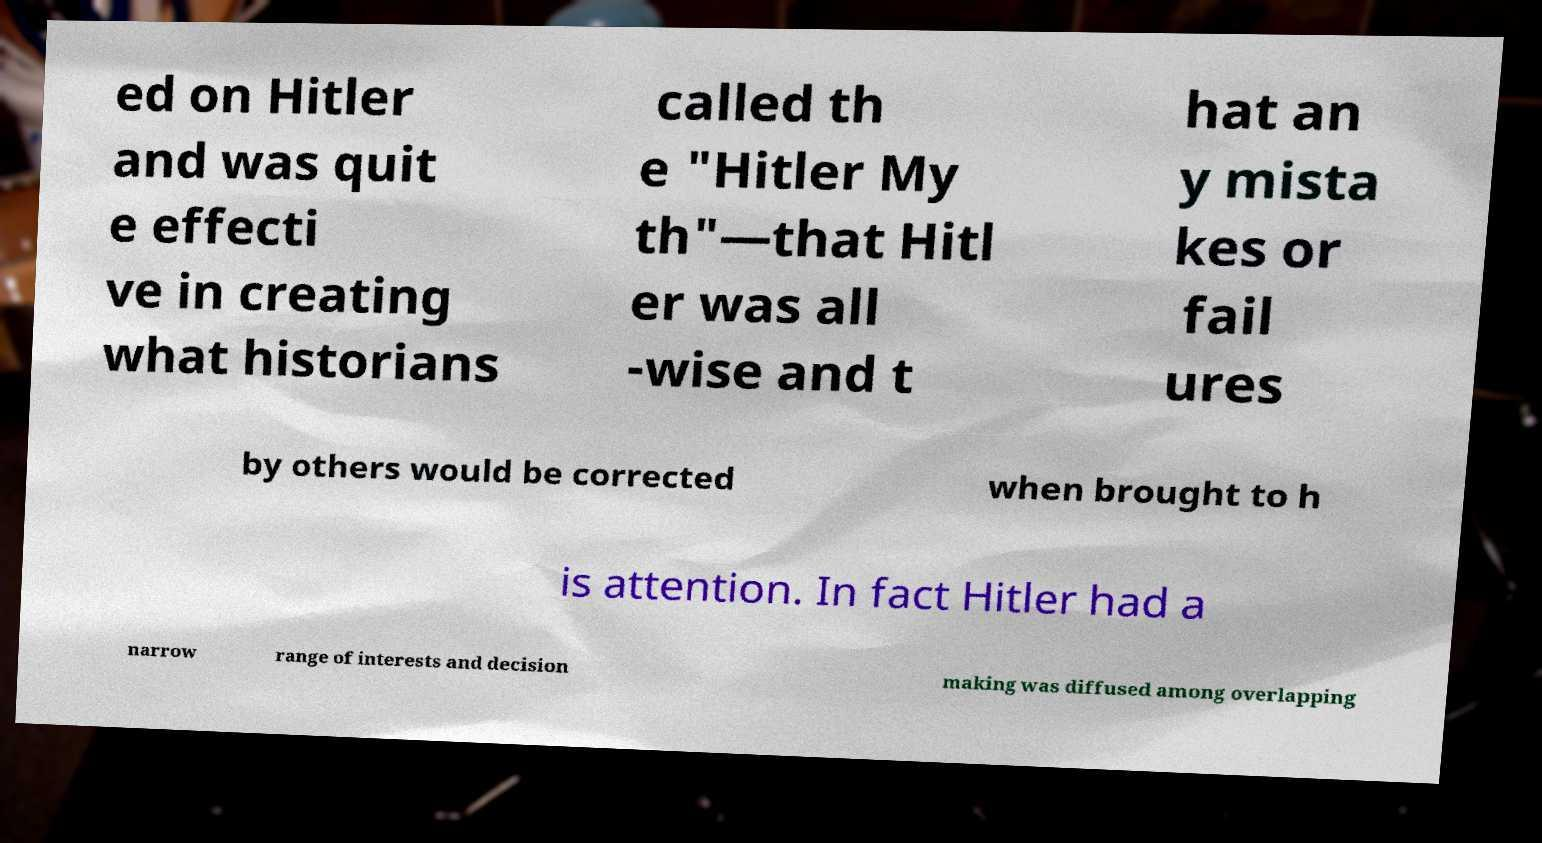Could you assist in decoding the text presented in this image and type it out clearly? ed on Hitler and was quit e effecti ve in creating what historians called th e "Hitler My th"—that Hitl er was all -wise and t hat an y mista kes or fail ures by others would be corrected when brought to h is attention. In fact Hitler had a narrow range of interests and decision making was diffused among overlapping 